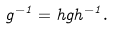Convert formula to latex. <formula><loc_0><loc_0><loc_500><loc_500>g ^ { - 1 } = h g h ^ { - 1 } .</formula> 